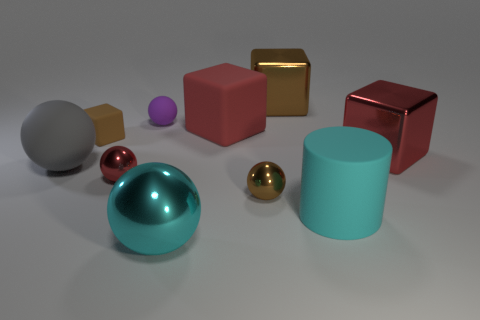Subtract all blue cylinders. How many red blocks are left? 2 Subtract all purple matte balls. How many balls are left? 4 Subtract 1 cubes. How many cubes are left? 3 Subtract all red spheres. How many spheres are left? 4 Subtract all brown spheres. Subtract all blue cubes. How many spheres are left? 4 Subtract all cylinders. How many objects are left? 9 Add 2 tiny balls. How many tiny balls exist? 5 Subtract 1 red cubes. How many objects are left? 9 Subtract all metal cylinders. Subtract all big cyan cylinders. How many objects are left? 9 Add 2 big blocks. How many big blocks are left? 5 